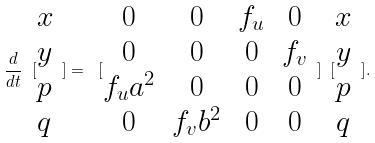<formula> <loc_0><loc_0><loc_500><loc_500>\frac { d } { d t } \ [ \begin{matrix} x \\ y \\ p \\ q \end{matrix} \ ] = \ [ \begin{matrix} 0 & 0 & f _ { u } & 0 \\ 0 & 0 & 0 & f _ { v } \\ f _ { u } a ^ { 2 } & 0 & 0 & 0 \\ 0 & f _ { v } b ^ { 2 } & 0 & 0 \end{matrix} \ ] \ [ \begin{matrix} x \\ y \\ p \\ q \end{matrix} \ ] .</formula> 